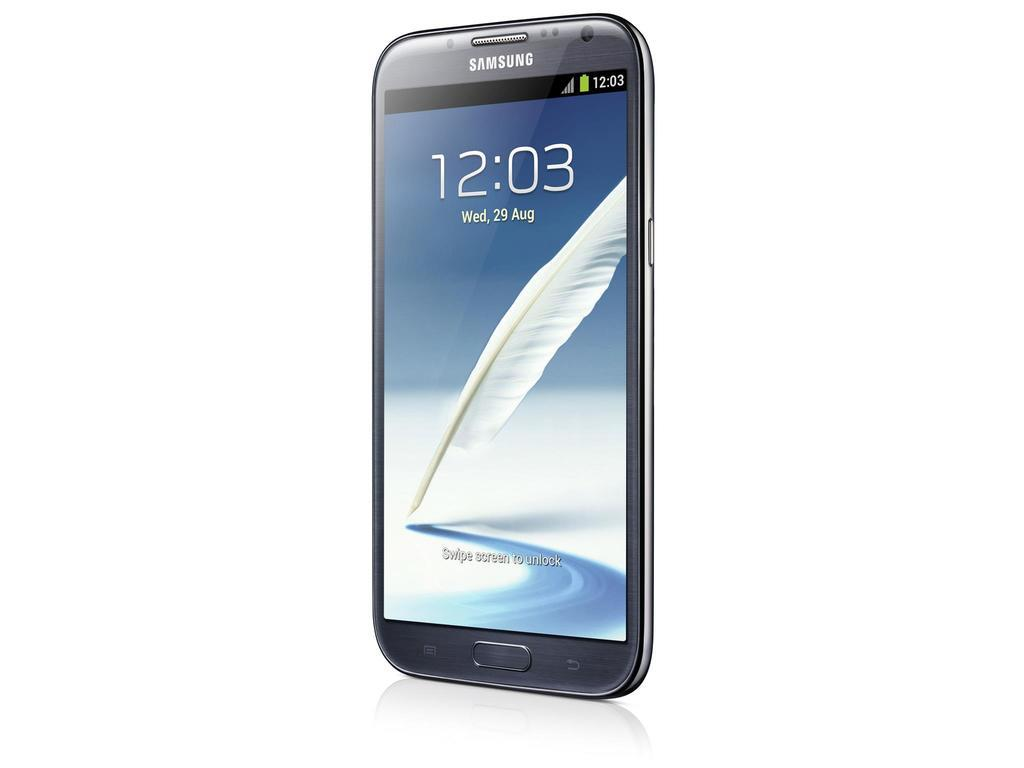<image>
Relay a brief, clear account of the picture shown. According to this Samsung phone, it is 12:03 on Wed, Aug 29. 